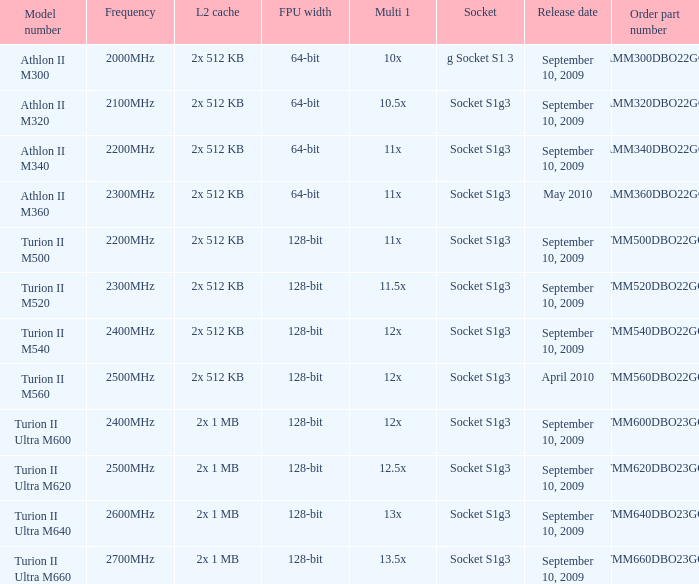What is the release date of the 2x 512 kb L2 cache with a 11x multi 1, and a FPU width of 128-bit? September 10, 2009. 